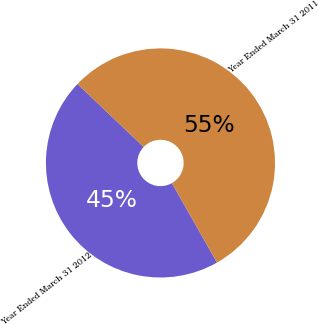Convert chart to OTSL. <chart><loc_0><loc_0><loc_500><loc_500><pie_chart><fcel>Year Ended March 31 2012<fcel>Year Ended March 31 2011<nl><fcel>45.32%<fcel>54.68%<nl></chart> 